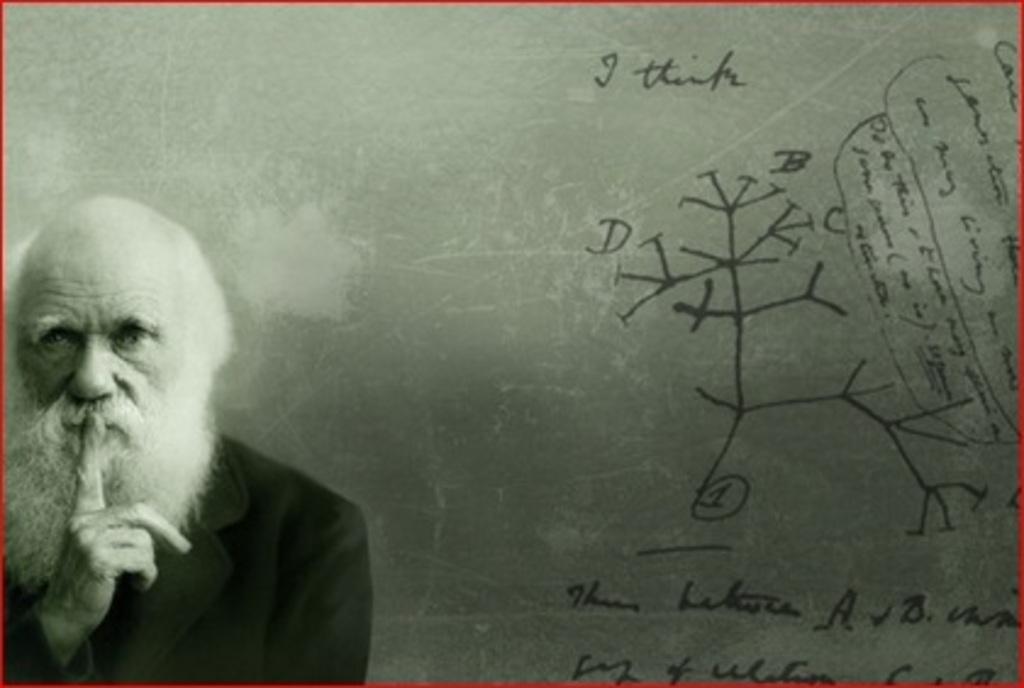Describe this image in one or two sentences. This is an edited picture. In this image there is a man standing. On the right side of the image there is text. At the back it looks like a board. 